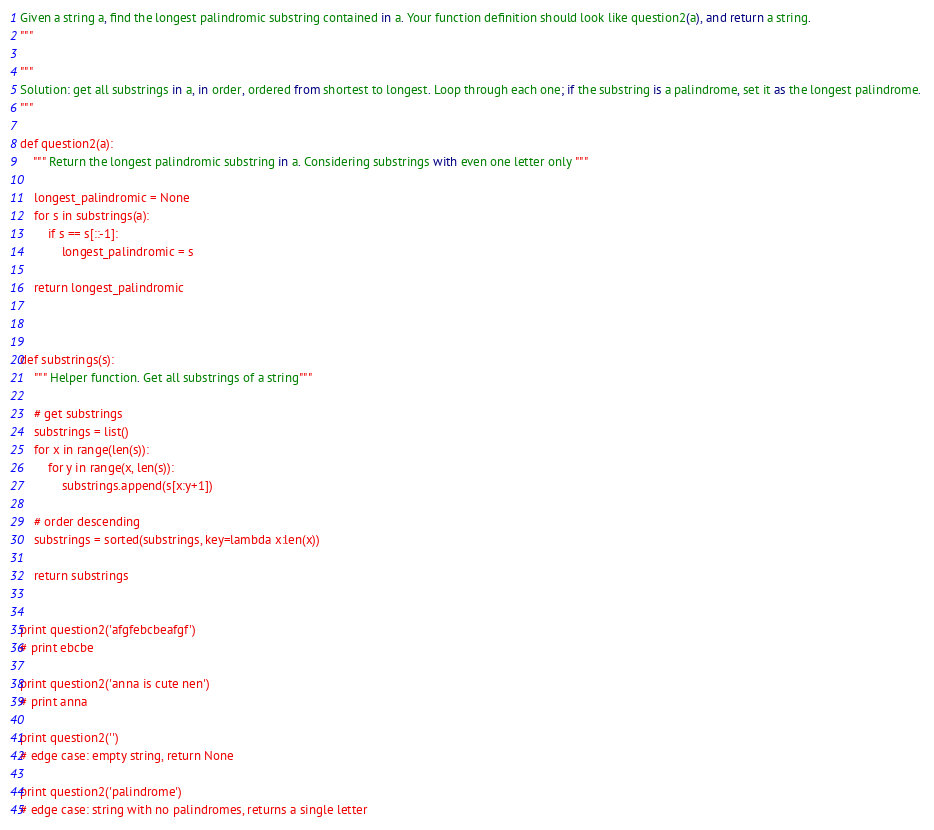<code> <loc_0><loc_0><loc_500><loc_500><_Python_>Given a string a, find the longest palindromic substring contained in a. Your function definition should look like question2(a), and return a string.
"""

"""
Solution: get all substrings in a, in order, ordered from shortest to longest. Loop through each one; if the substring is a palindrome, set it as the longest palindrome. 
"""

def question2(a):
    """ Return the longest palindromic substring in a. Considering substrings with even one letter only """

    longest_palindromic = None
    for s in substrings(a):
        if s == s[::-1]:
            longest_palindromic = s

    return longest_palindromic



def substrings(s):
    """ Helper function. Get all substrings of a string"""

    # get substrings
    substrings = list()
    for x in range(len(s)):
        for y in range(x, len(s)):
            substrings.append(s[x:y+1])

    # order descending
    substrings = sorted(substrings, key=lambda x:len(x))

    return substrings


print question2('afgfebcbeafgf')
# print ebcbe

print question2('anna is cute nen')
# print anna

print question2('')
# edge case: empty string, return None

print question2('palindrome')
# edge case: string with no palindromes, returns a single letter</code> 